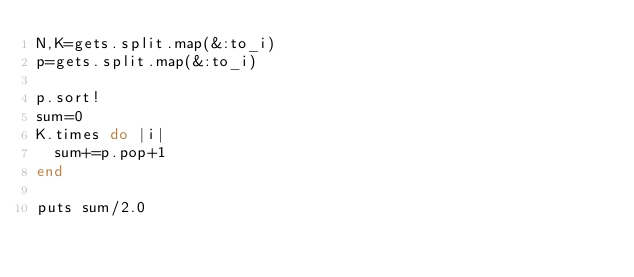Convert code to text. <code><loc_0><loc_0><loc_500><loc_500><_Ruby_>N,K=gets.split.map(&:to_i)
p=gets.split.map(&:to_i)

p.sort!
sum=0
K.times do |i|
  sum+=p.pop+1
end

puts sum/2.0</code> 